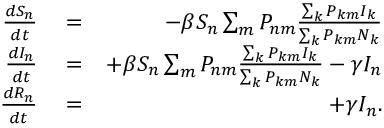Convert formula to latex. <formula><loc_0><loc_0><loc_500><loc_500>\begin{array} { r l r } { \frac { d S _ { n } } { d t } } & = } & { - \beta S _ { n } \sum _ { m } P _ { n m } \frac { \sum _ { k } P _ { k m } I _ { k } } { \sum _ { k } P _ { k m } N _ { k } } } \\ { \frac { d I _ { n } } { d t } } & = } & { + \beta S _ { n } \sum _ { m } P _ { n m } \frac { \sum _ { k } P _ { k m } I _ { k } } { \sum _ { k } P _ { k m } N _ { k } } - \gamma I _ { n } } \\ { \frac { d R _ { n } } { d t } } & = } & { + \gamma I _ { n } . } \end{array}</formula> 